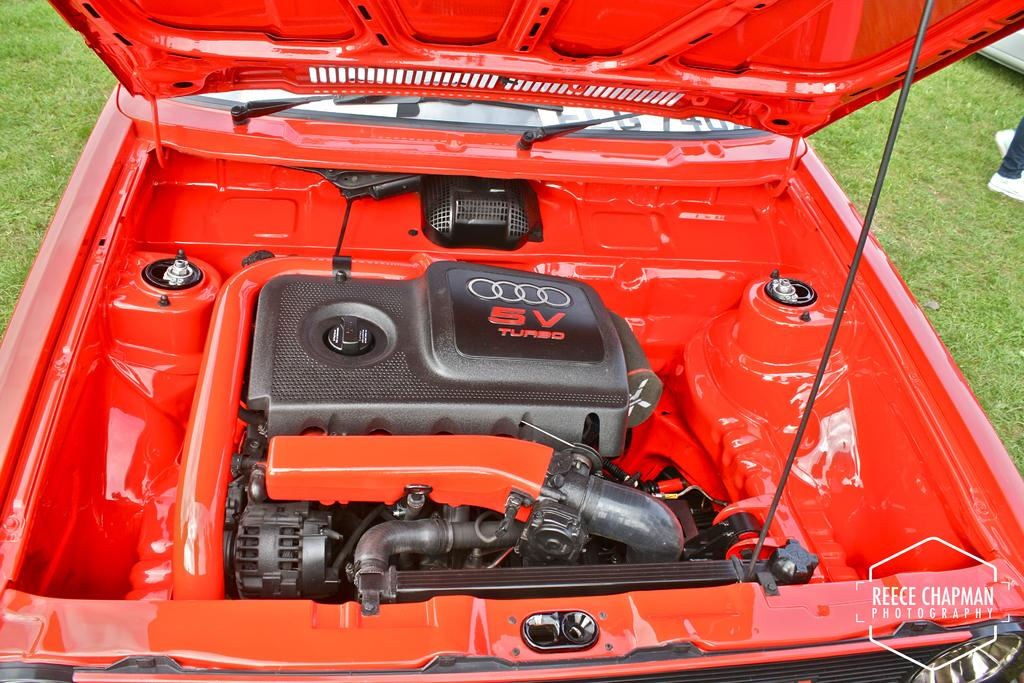What part of a car is visible in the image? There is a hood of a car in the image. Can you describe the condition or appearance of the car's hood? The provided facts do not include any details about the condition or appearance of the hood. Is the car's hood touching the ground in the image? The provided facts do not include any information about the car's hood touching the ground. Is there a cellar visible in the image? There is no mention of a cellar in the provided facts, and it is not visible in the image. Is the car's hood on a slope in the image? The provided facts do not include any information about the car's hood being on a slope. 